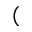Convert formula to latex. <formula><loc_0><loc_0><loc_500><loc_500>(</formula> 